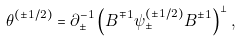Convert formula to latex. <formula><loc_0><loc_0><loc_500><loc_500>\theta ^ { ( \pm 1 / 2 ) } = \partial _ { \pm } ^ { - 1 } \left ( B ^ { \mp 1 } \psi _ { \pm } ^ { \left ( \pm 1 / 2 \right ) } B ^ { \pm 1 } \right ) ^ { \perp } ,</formula> 